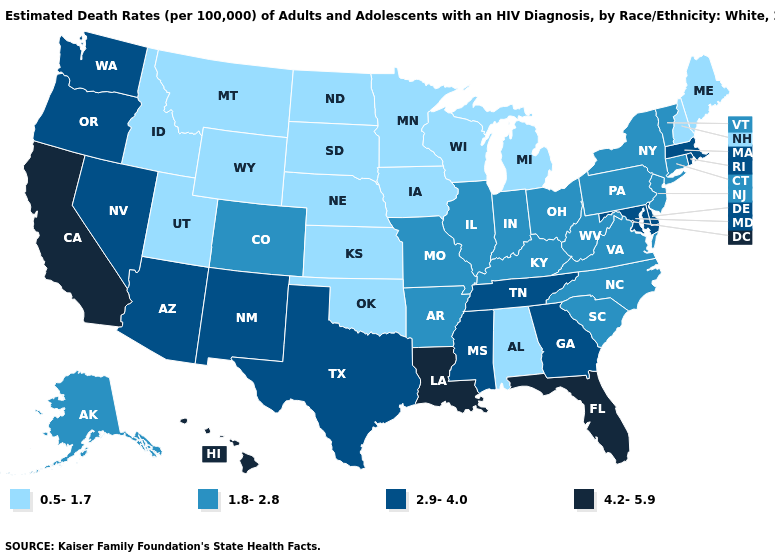Does Ohio have the highest value in the MidWest?
Answer briefly. Yes. Does Wyoming have the lowest value in the USA?
Quick response, please. Yes. Which states have the lowest value in the USA?
Quick response, please. Alabama, Idaho, Iowa, Kansas, Maine, Michigan, Minnesota, Montana, Nebraska, New Hampshire, North Dakota, Oklahoma, South Dakota, Utah, Wisconsin, Wyoming. What is the value of Connecticut?
Answer briefly. 1.8-2.8. Does the first symbol in the legend represent the smallest category?
Short answer required. Yes. Among the states that border Delaware , does New Jersey have the lowest value?
Answer briefly. Yes. Which states have the highest value in the USA?
Short answer required. California, Florida, Hawaii, Louisiana. What is the value of Montana?
Quick response, please. 0.5-1.7. What is the highest value in the West ?
Concise answer only. 4.2-5.9. Name the states that have a value in the range 1.8-2.8?
Be succinct. Alaska, Arkansas, Colorado, Connecticut, Illinois, Indiana, Kentucky, Missouri, New Jersey, New York, North Carolina, Ohio, Pennsylvania, South Carolina, Vermont, Virginia, West Virginia. Name the states that have a value in the range 1.8-2.8?
Be succinct. Alaska, Arkansas, Colorado, Connecticut, Illinois, Indiana, Kentucky, Missouri, New Jersey, New York, North Carolina, Ohio, Pennsylvania, South Carolina, Vermont, Virginia, West Virginia. What is the value of Illinois?
Keep it brief. 1.8-2.8. Name the states that have a value in the range 2.9-4.0?
Concise answer only. Arizona, Delaware, Georgia, Maryland, Massachusetts, Mississippi, Nevada, New Mexico, Oregon, Rhode Island, Tennessee, Texas, Washington. Name the states that have a value in the range 0.5-1.7?
Concise answer only. Alabama, Idaho, Iowa, Kansas, Maine, Michigan, Minnesota, Montana, Nebraska, New Hampshire, North Dakota, Oklahoma, South Dakota, Utah, Wisconsin, Wyoming. Does the map have missing data?
Be succinct. No. 